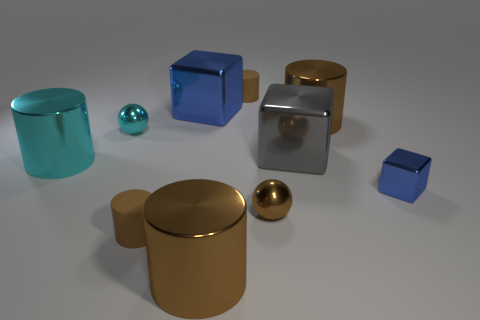How many brown cylinders must be subtracted to get 2 brown cylinders? 2 Subtract all gray spheres. How many brown cylinders are left? 4 Subtract all cyan cylinders. How many cylinders are left? 4 Subtract all yellow cylinders. Subtract all yellow blocks. How many cylinders are left? 5 Subtract all spheres. How many objects are left? 8 Subtract 0 green cubes. How many objects are left? 10 Subtract all large shiny cylinders. Subtract all small spheres. How many objects are left? 5 Add 7 cyan cylinders. How many cyan cylinders are left? 8 Add 3 tiny rubber cylinders. How many tiny rubber cylinders exist? 5 